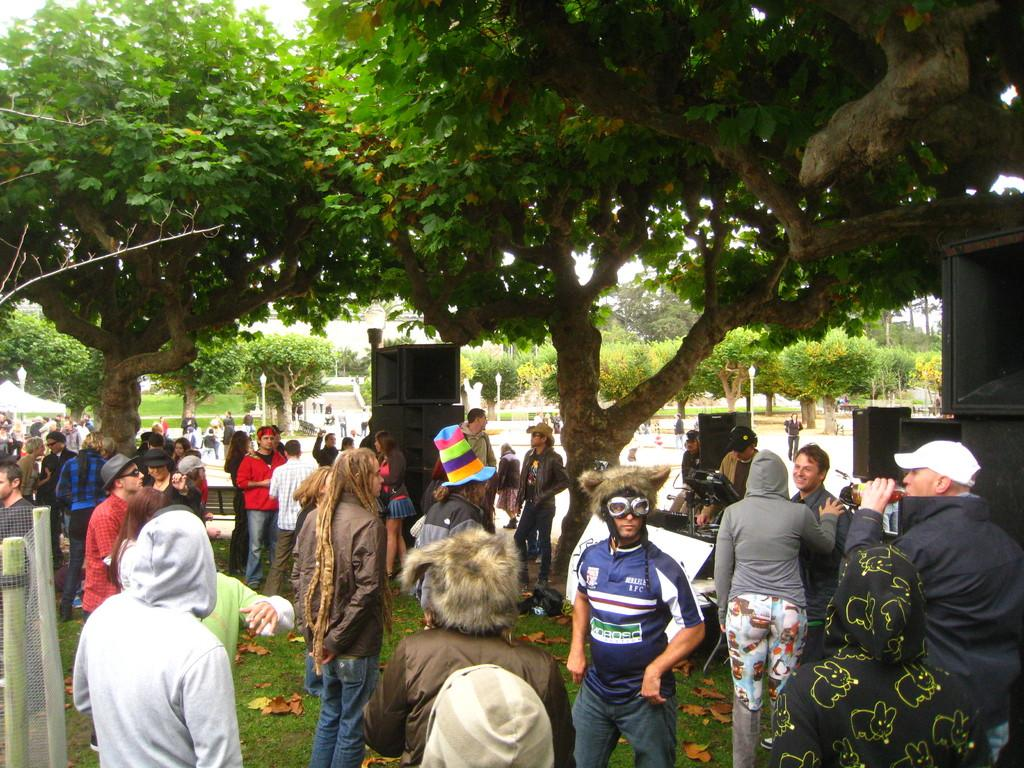How many people are in the image? There is a group of people in the image, but the exact number is not specified. What type of terrain is visible in the image? There is grass and trees in the image, suggesting a natural setting. What objects are present for sound amplification? There are speakers in the image. What can be seen in the background of the image? There are trees and lights on poles in the background of the image. What type of wave can be seen crashing on the shore in the image? There is no wave or shore visible in the image; it features a group of people, grass, trees, speakers, and lights on poles in the background. 